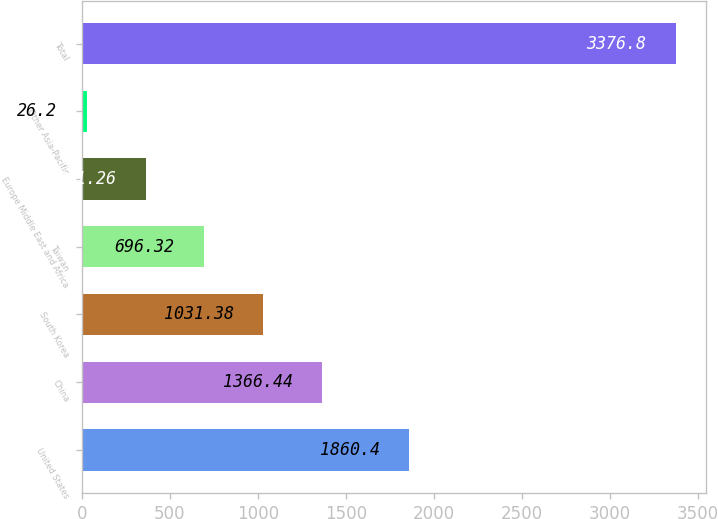Convert chart. <chart><loc_0><loc_0><loc_500><loc_500><bar_chart><fcel>United States<fcel>China<fcel>South Korea<fcel>Taiwan<fcel>Europe Middle East and Africa<fcel>Other Asia-Pacific<fcel>Total<nl><fcel>1860.4<fcel>1366.44<fcel>1031.38<fcel>696.32<fcel>361.26<fcel>26.2<fcel>3376.8<nl></chart> 